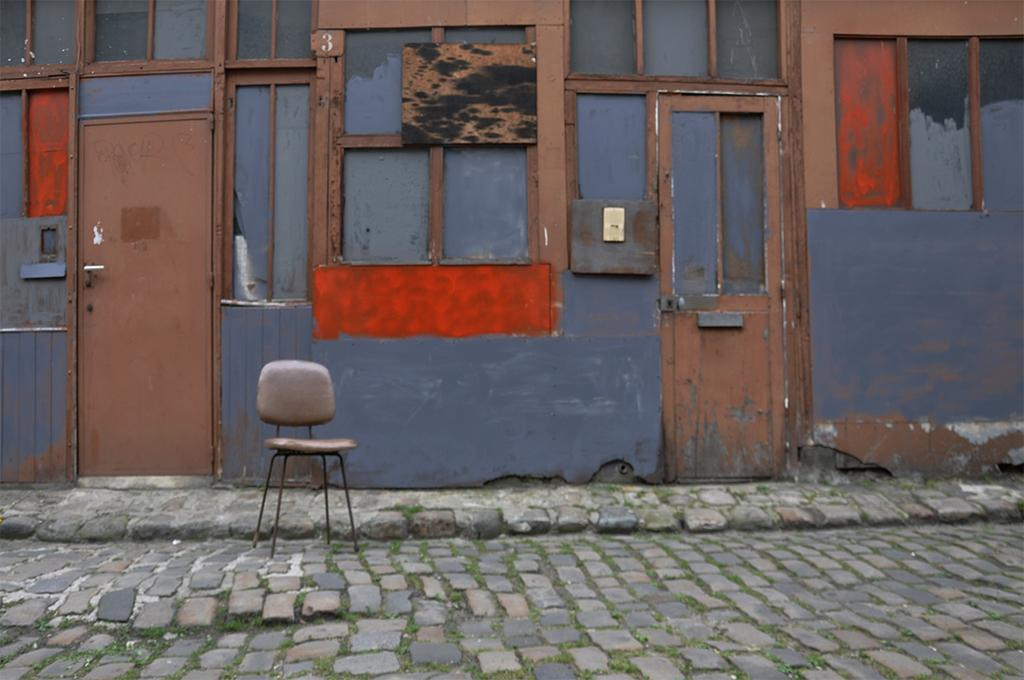What architectural features are located in the center of the image? There are windows and doors in the center of the image. What type of structure do these windows and doors belong to? These windows and doors belong to a building. What piece of furniture can be seen at the bottom of the image? There is a chair at the bottom of the image. Where is the chair located in relation to the building? The chair is on the road. What type of store is located near the chair in the image? There is no store present in the image; it only features a chair on the road and windows and doors belonging to a building. Is there a quilt draped over the chair in the image? There is no quilt present in the image; only a chair is visible on the road. 